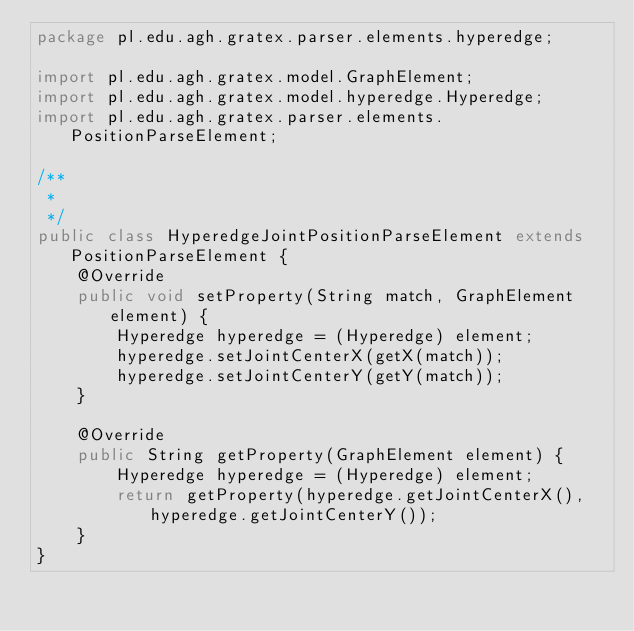Convert code to text. <code><loc_0><loc_0><loc_500><loc_500><_Java_>package pl.edu.agh.gratex.parser.elements.hyperedge;

import pl.edu.agh.gratex.model.GraphElement;
import pl.edu.agh.gratex.model.hyperedge.Hyperedge;
import pl.edu.agh.gratex.parser.elements.PositionParseElement;

/**
 *
 */
public class HyperedgeJointPositionParseElement extends PositionParseElement {
    @Override
    public void setProperty(String match, GraphElement element) {
        Hyperedge hyperedge = (Hyperedge) element;
        hyperedge.setJointCenterX(getX(match));
        hyperedge.setJointCenterY(getY(match));
    }

    @Override
    public String getProperty(GraphElement element) {
        Hyperedge hyperedge = (Hyperedge) element;
        return getProperty(hyperedge.getJointCenterX(), hyperedge.getJointCenterY());
    }
}
</code> 